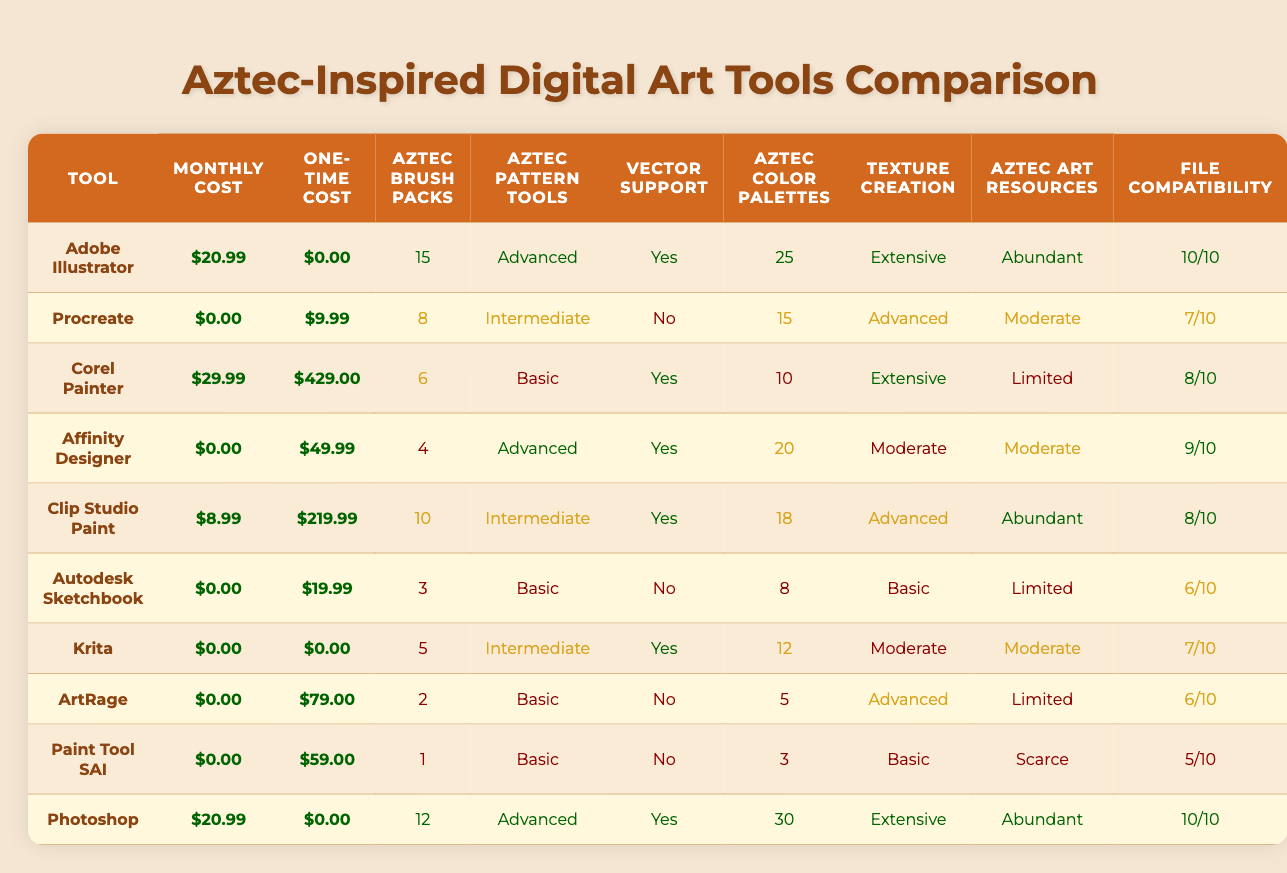What is the monthly subscription cost of Adobe Illustrator? The table lists the monthly subscription cost for Adobe Illustrator as $20.99.
Answer: $20.99 Which tool has the highest one-time purchase cost? According to the table, Corel Painter has the highest one-time purchase cost at $429.00.
Answer: Corel Painter How many Aztec-inspired brush packs are available for Clip Studio Paint? The table indicates that Clip Studio Paint has 10 Aztec-inspired brush packs available.
Answer: 10 Is there vector graphics support for Autodesk Sketchbook? The table shows that Autodesk Sketchbook does not have vector graphics support.
Answer: No What is the average file format compatibility score for the tools listed? To find the average, sum the scores (10 + 7 + 8 + 9 + 8 + 6 + 7 + 6 + 5 + 10) = 78, and divide by 10, which gives 7.8.
Answer: 7.8 Which tool provides the most extensive texture creation features? The table indicates that both Adobe Illustrator and Corel Painter offer extensive texture creation features.
Answer: Adobe Illustrator and Corel Painter How many tools have monthly subscriptions costing more than $10? Based on the table, Adobe Illustrator and Photoshop are the only tools with monthly subscriptions greater than $10, totaling 2 tools.
Answer: 2 Are there any tools that have both a one-time purchase cost and a free monthly subscription? From the table, Procreate, Krita, and ArtRage have a one-time purchase cost but do not have a monthly subscription.
Answer: Yes Which tool has the least number of color palette presets for Aztec art? The least number of color palette presets, according to the table, is 3 for Paint Tool SAI.
Answer: Paint Tool SAI If you were to choose a tool that offers abundant learning resources and extensive texture creation features, which tool would you select? Checking the table, Adobe Illustrator fits both criteria with abundant learning resources and extensive texture creation capabilities.
Answer: Adobe Illustrator 